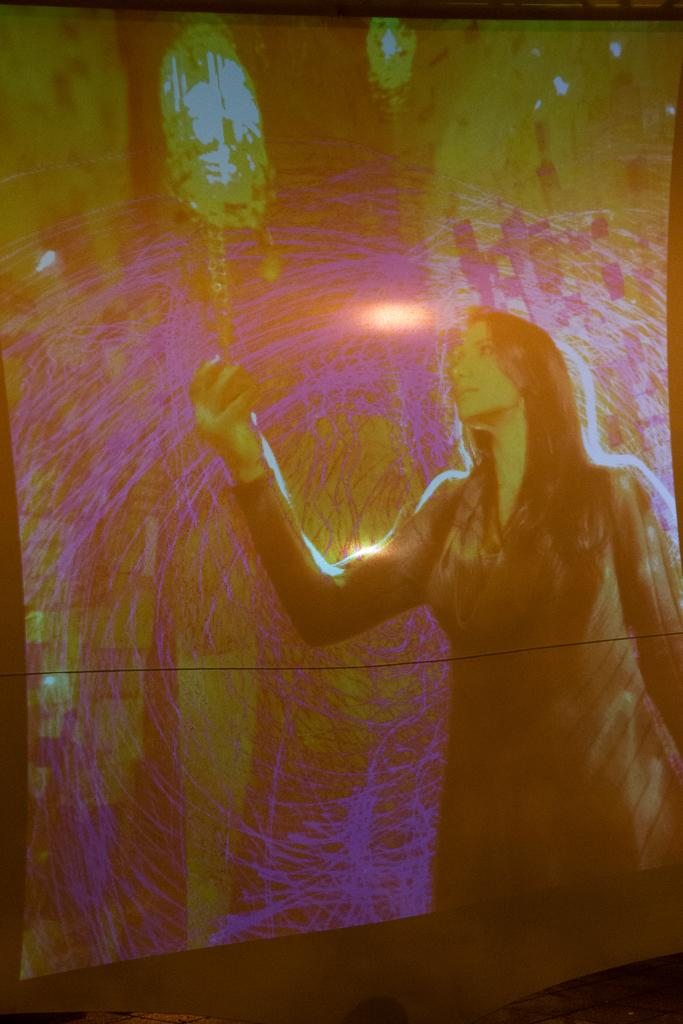What is the main subject in the foreground of the image? There is a wall painting in the foreground of the image. What is the wall painting depicting? The wall painting depicts a woman holding an object in her hand. Can you describe the setting in which the image may have been taken? The image may have been taken in a hall. How many potatoes are visible in the image? There are no potatoes present in the image. What impulse might have led to the creation of the wall painting? The provided facts do not give any information about the impulse behind the creation of the wall painting, so it cannot be determined from the image. 